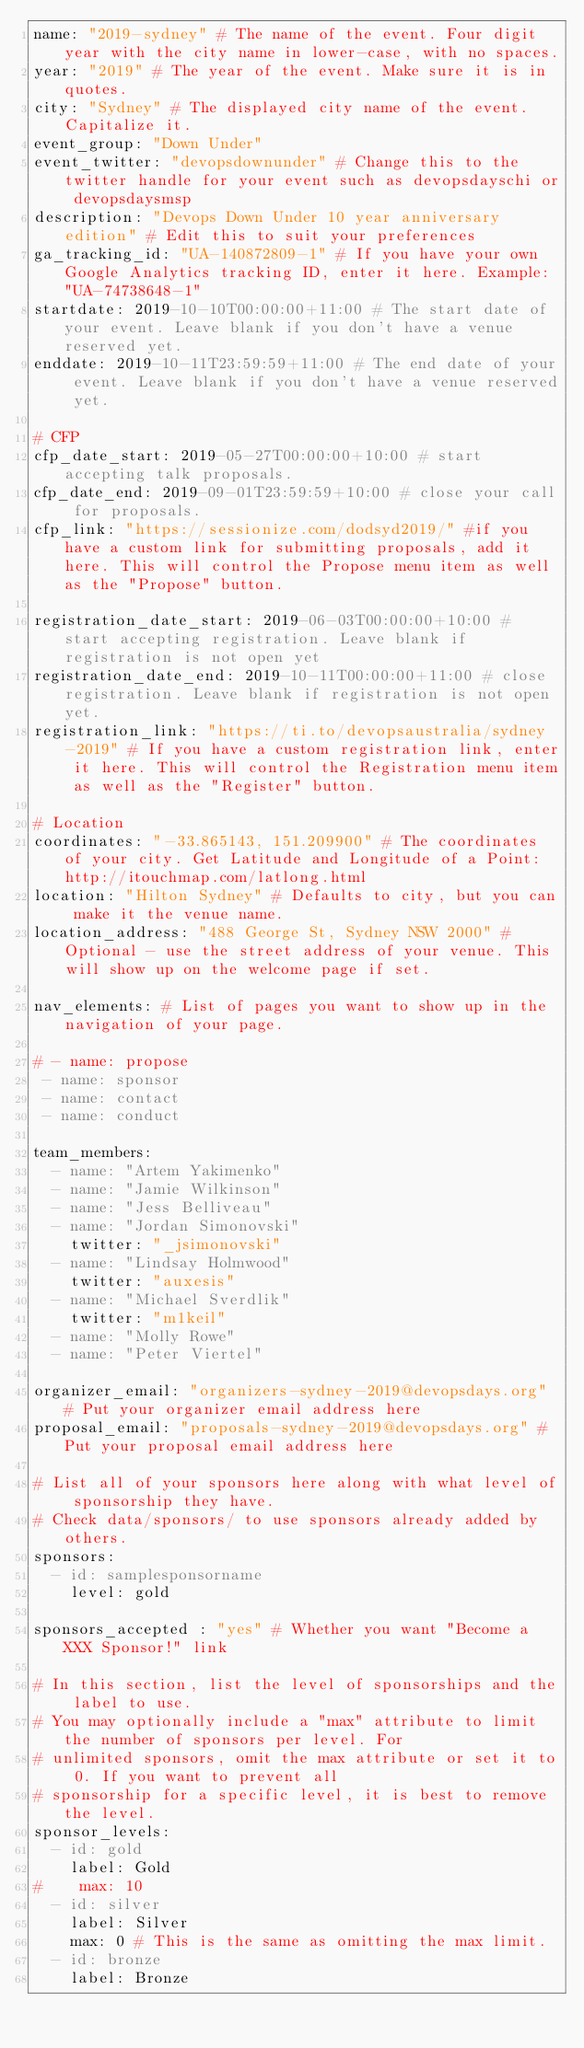<code> <loc_0><loc_0><loc_500><loc_500><_YAML_>name: "2019-sydney" # The name of the event. Four digit year with the city name in lower-case, with no spaces.
year: "2019" # The year of the event. Make sure it is in quotes.
city: "Sydney" # The displayed city name of the event. Capitalize it.
event_group: "Down Under"
event_twitter: "devopsdownunder" # Change this to the twitter handle for your event such as devopsdayschi or devopsdaysmsp
description: "Devops Down Under 10 year anniversary edition" # Edit this to suit your preferences
ga_tracking_id: "UA-140872809-1" # If you have your own Google Analytics tracking ID, enter it here. Example: "UA-74738648-1"
startdate: 2019-10-10T00:00:00+11:00 # The start date of your event. Leave blank if you don't have a venue reserved yet.
enddate: 2019-10-11T23:59:59+11:00 # The end date of your event. Leave blank if you don't have a venue reserved yet.

# CFP
cfp_date_start: 2019-05-27T00:00:00+10:00 # start accepting talk proposals.
cfp_date_end: 2019-09-01T23:59:59+10:00 # close your call for proposals.
cfp_link: "https://sessionize.com/dodsyd2019/" #if you have a custom link for submitting proposals, add it here. This will control the Propose menu item as well as the "Propose" button.

registration_date_start: 2019-06-03T00:00:00+10:00 # start accepting registration. Leave blank if registration is not open yet
registration_date_end: 2019-10-11T00:00:00+11:00 # close registration. Leave blank if registration is not open yet.
registration_link: "https://ti.to/devopsaustralia/sydney-2019" # If you have a custom registration link, enter it here. This will control the Registration menu item as well as the "Register" button.

# Location
coordinates: "-33.865143, 151.209900" # The coordinates of your city. Get Latitude and Longitude of a Point: http://itouchmap.com/latlong.html
location: "Hilton Sydney" # Defaults to city, but you can make it the venue name.
location_address: "488 George St, Sydney NSW 2000" #Optional - use the street address of your venue. This will show up on the welcome page if set.

nav_elements: # List of pages you want to show up in the navigation of your page.

# - name: propose
 - name: sponsor
 - name: contact
 - name: conduct

team_members:
  - name: "Artem Yakimenko"
  - name: "Jamie Wilkinson"
  - name: "Jess Belliveau"
  - name: "Jordan Simonovski"
    twitter: "_jsimonovski"
  - name: "Lindsay Holmwood"
    twitter: "auxesis"
  - name: "Michael Sverdlik"
    twitter: "m1keil"
  - name: "Molly Rowe"
  - name: "Peter Viertel"

organizer_email: "organizers-sydney-2019@devopsdays.org" # Put your organizer email address here
proposal_email: "proposals-sydney-2019@devopsdays.org" # Put your proposal email address here

# List all of your sponsors here along with what level of sponsorship they have.
# Check data/sponsors/ to use sponsors already added by others.
sponsors:
  - id: samplesponsorname
    level: gold

sponsors_accepted : "yes" # Whether you want "Become a XXX Sponsor!" link

# In this section, list the level of sponsorships and the label to use.
# You may optionally include a "max" attribute to limit the number of sponsors per level. For
# unlimited sponsors, omit the max attribute or set it to 0. If you want to prevent all
# sponsorship for a specific level, it is best to remove the level.
sponsor_levels:
  - id: gold
    label: Gold
#    max: 10
  - id: silver
    label: Silver
    max: 0 # This is the same as omitting the max limit.
  - id: bronze
    label: Bronze
</code> 